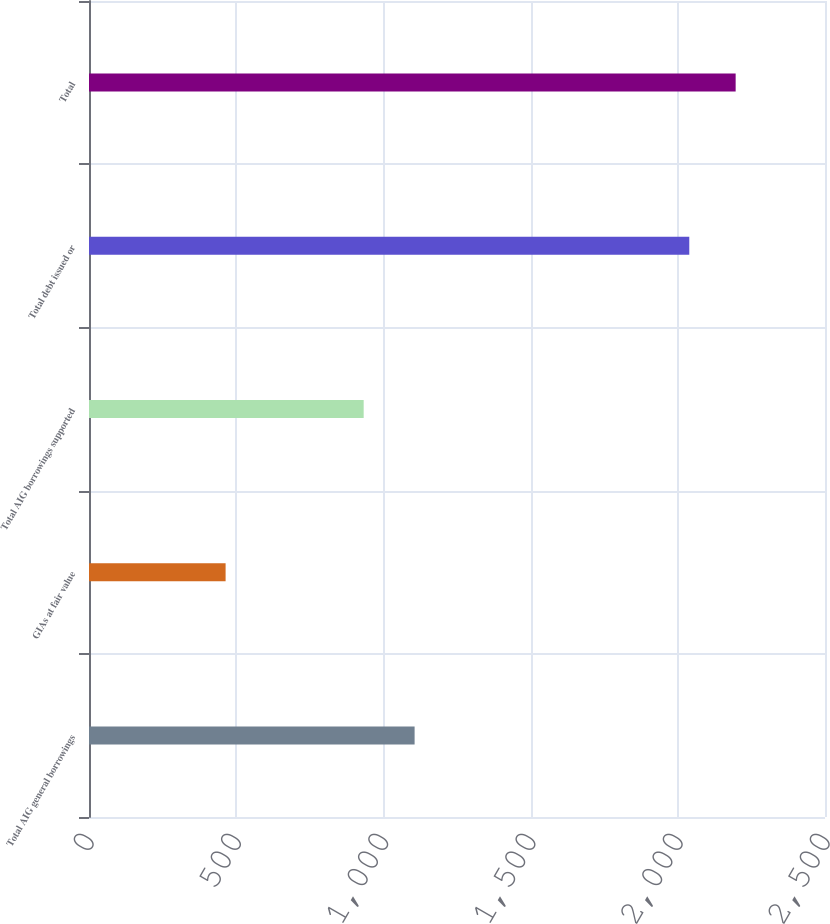Convert chart. <chart><loc_0><loc_0><loc_500><loc_500><bar_chart><fcel>Total AIG general borrowings<fcel>GIAs at fair value<fcel>Total AIG borrowings supported<fcel>Total debt issued or<fcel>Total<nl><fcel>1106<fcel>464<fcel>933<fcel>2039<fcel>2196.5<nl></chart> 